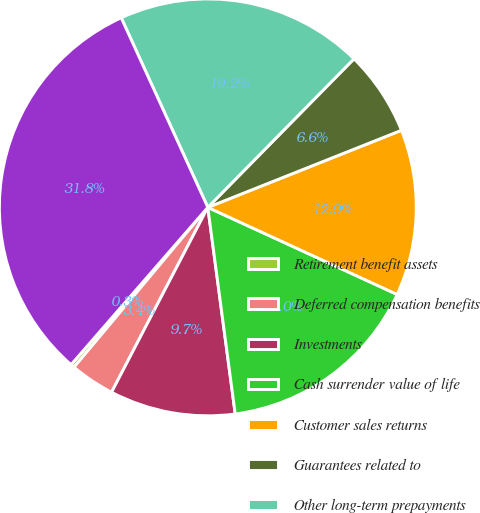<chart> <loc_0><loc_0><loc_500><loc_500><pie_chart><fcel>Retirement benefit assets<fcel>Deferred compensation benefits<fcel>Investments<fcel>Cash surrender value of life<fcel>Customer sales returns<fcel>Guarantees related to<fcel>Other long-term prepayments<fcel>Total other assets<nl><fcel>0.3%<fcel>3.45%<fcel>9.74%<fcel>16.04%<fcel>12.89%<fcel>6.6%<fcel>19.19%<fcel>31.79%<nl></chart> 